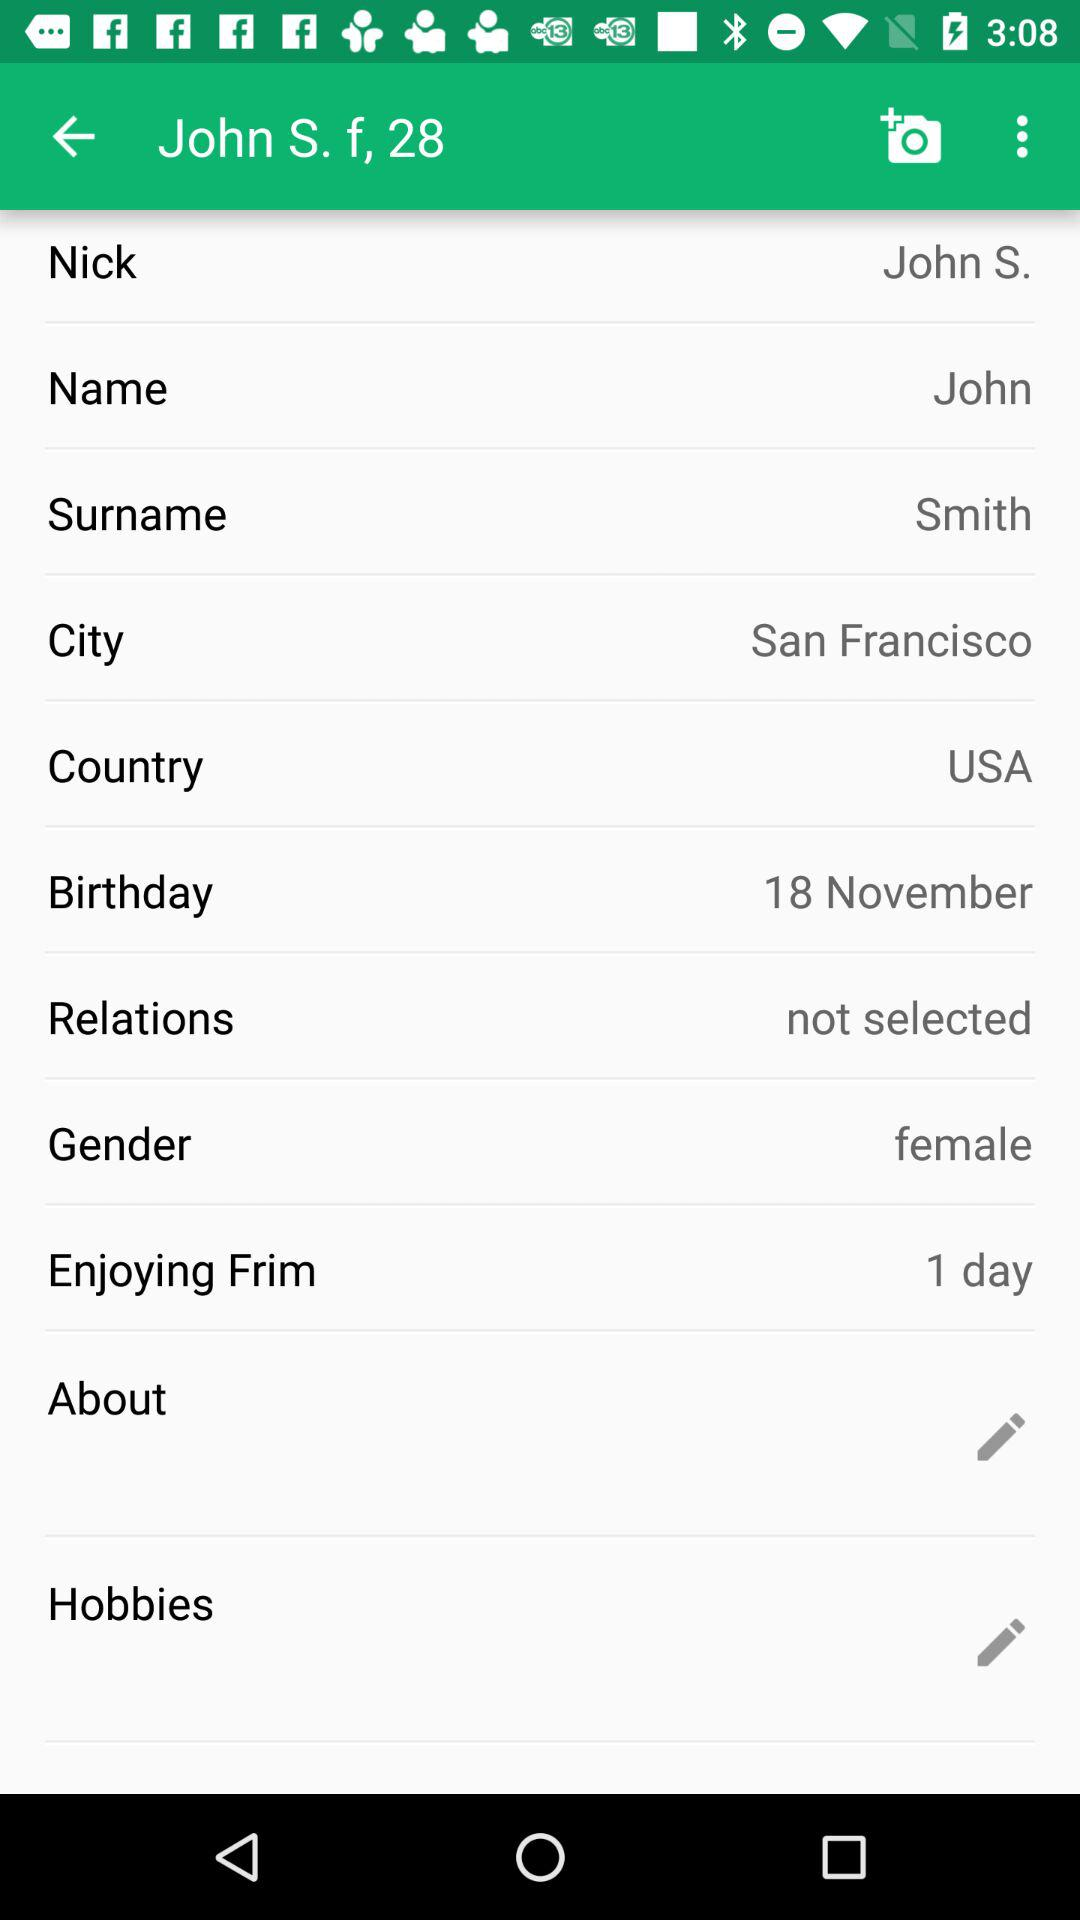What is the given gender? The given gender is female. 